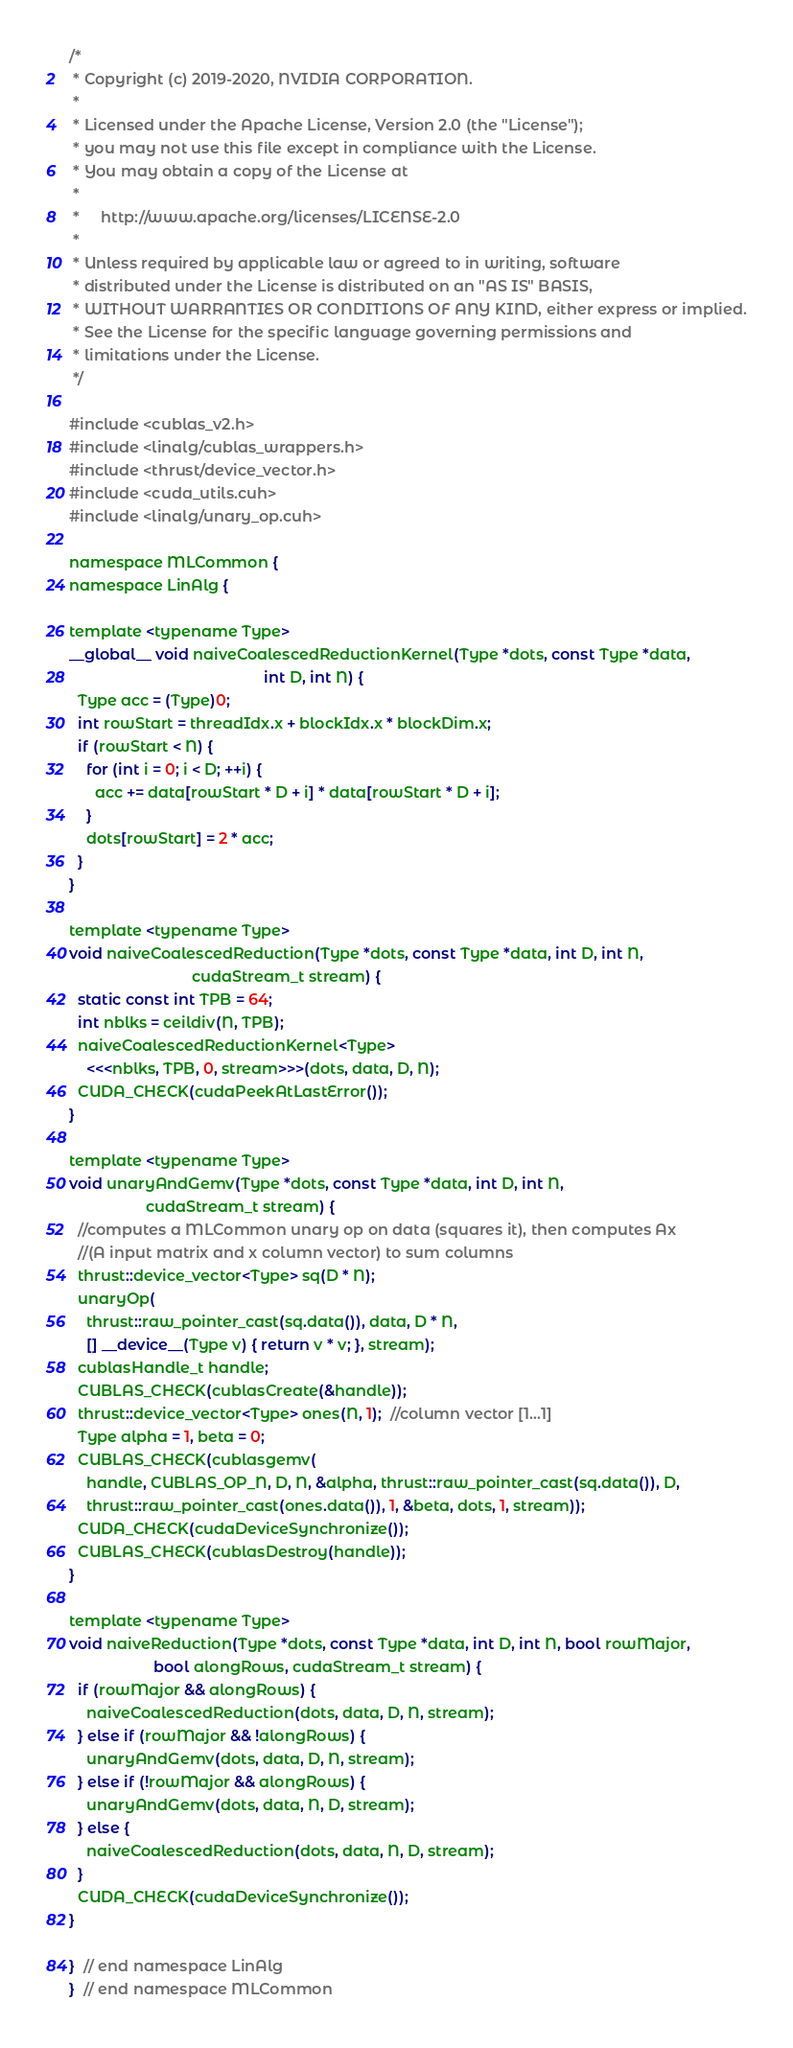<code> <loc_0><loc_0><loc_500><loc_500><_Cuda_>/*
 * Copyright (c) 2019-2020, NVIDIA CORPORATION.
 *
 * Licensed under the Apache License, Version 2.0 (the "License");
 * you may not use this file except in compliance with the License.
 * You may obtain a copy of the License at
 *
 *     http://www.apache.org/licenses/LICENSE-2.0
 *
 * Unless required by applicable law or agreed to in writing, software
 * distributed under the License is distributed on an "AS IS" BASIS,
 * WITHOUT WARRANTIES OR CONDITIONS OF ANY KIND, either express or implied.
 * See the License for the specific language governing permissions and
 * limitations under the License.
 */

#include <cublas_v2.h>
#include <linalg/cublas_wrappers.h>
#include <thrust/device_vector.h>
#include <cuda_utils.cuh>
#include <linalg/unary_op.cuh>

namespace MLCommon {
namespace LinAlg {

template <typename Type>
__global__ void naiveCoalescedReductionKernel(Type *dots, const Type *data,
                                              int D, int N) {
  Type acc = (Type)0;
  int rowStart = threadIdx.x + blockIdx.x * blockDim.x;
  if (rowStart < N) {
    for (int i = 0; i < D; ++i) {
      acc += data[rowStart * D + i] * data[rowStart * D + i];
    }
    dots[rowStart] = 2 * acc;
  }
}

template <typename Type>
void naiveCoalescedReduction(Type *dots, const Type *data, int D, int N,
                             cudaStream_t stream) {
  static const int TPB = 64;
  int nblks = ceildiv(N, TPB);
  naiveCoalescedReductionKernel<Type>
    <<<nblks, TPB, 0, stream>>>(dots, data, D, N);
  CUDA_CHECK(cudaPeekAtLastError());
}

template <typename Type>
void unaryAndGemv(Type *dots, const Type *data, int D, int N,
                  cudaStream_t stream) {
  //computes a MLCommon unary op on data (squares it), then computes Ax
  //(A input matrix and x column vector) to sum columns
  thrust::device_vector<Type> sq(D * N);
  unaryOp(
    thrust::raw_pointer_cast(sq.data()), data, D * N,
    [] __device__(Type v) { return v * v; }, stream);
  cublasHandle_t handle;
  CUBLAS_CHECK(cublasCreate(&handle));
  thrust::device_vector<Type> ones(N, 1);  //column vector [1...1]
  Type alpha = 1, beta = 0;
  CUBLAS_CHECK(cublasgemv(
    handle, CUBLAS_OP_N, D, N, &alpha, thrust::raw_pointer_cast(sq.data()), D,
    thrust::raw_pointer_cast(ones.data()), 1, &beta, dots, 1, stream));
  CUDA_CHECK(cudaDeviceSynchronize());
  CUBLAS_CHECK(cublasDestroy(handle));
}

template <typename Type>
void naiveReduction(Type *dots, const Type *data, int D, int N, bool rowMajor,
                    bool alongRows, cudaStream_t stream) {
  if (rowMajor && alongRows) {
    naiveCoalescedReduction(dots, data, D, N, stream);
  } else if (rowMajor && !alongRows) {
    unaryAndGemv(dots, data, D, N, stream);
  } else if (!rowMajor && alongRows) {
    unaryAndGemv(dots, data, N, D, stream);
  } else {
    naiveCoalescedReduction(dots, data, N, D, stream);
  }
  CUDA_CHECK(cudaDeviceSynchronize());
}

}  // end namespace LinAlg
}  // end namespace MLCommon
</code> 